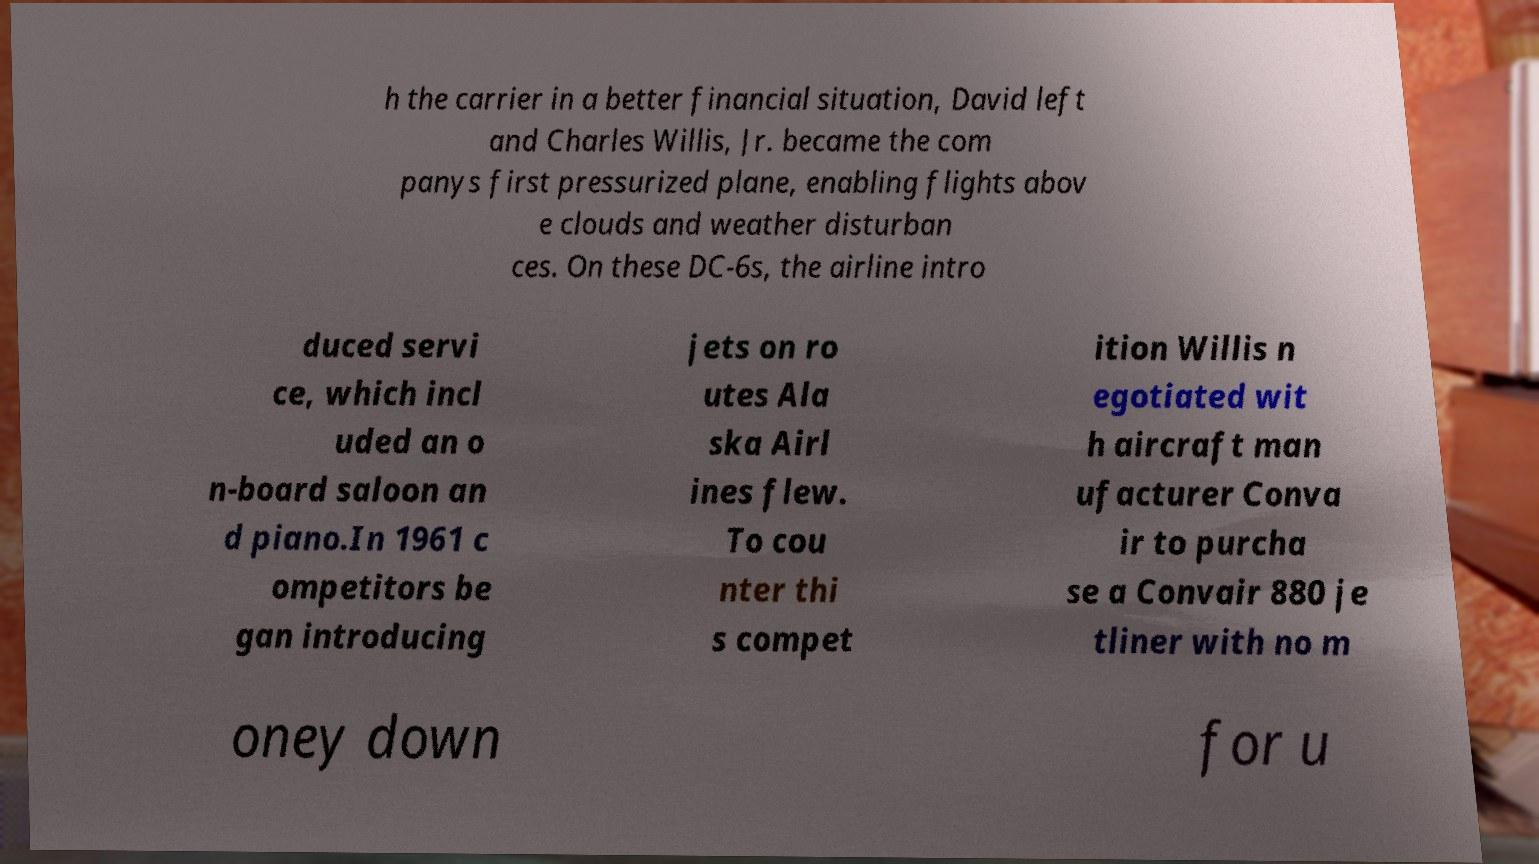Can you read and provide the text displayed in the image?This photo seems to have some interesting text. Can you extract and type it out for me? h the carrier in a better financial situation, David left and Charles Willis, Jr. became the com panys first pressurized plane, enabling flights abov e clouds and weather disturban ces. On these DC-6s, the airline intro duced servi ce, which incl uded an o n-board saloon an d piano.In 1961 c ompetitors be gan introducing jets on ro utes Ala ska Airl ines flew. To cou nter thi s compet ition Willis n egotiated wit h aircraft man ufacturer Conva ir to purcha se a Convair 880 je tliner with no m oney down for u 